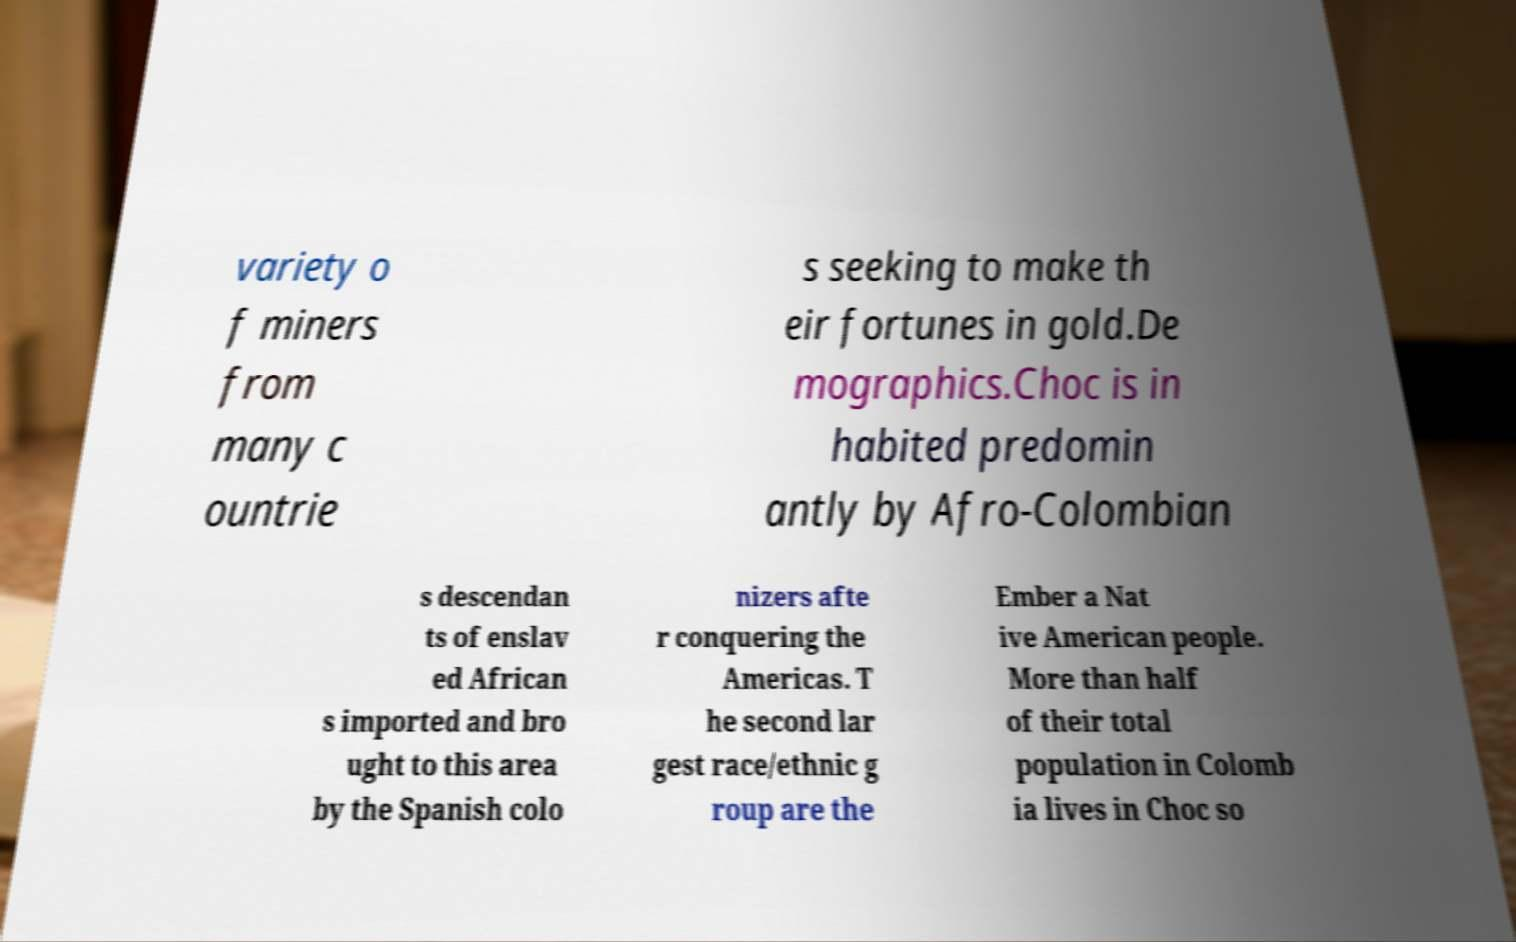Please identify and transcribe the text found in this image. variety o f miners from many c ountrie s seeking to make th eir fortunes in gold.De mographics.Choc is in habited predomin antly by Afro-Colombian s descendan ts of enslav ed African s imported and bro ught to this area by the Spanish colo nizers afte r conquering the Americas. T he second lar gest race/ethnic g roup are the Ember a Nat ive American people. More than half of their total population in Colomb ia lives in Choc so 